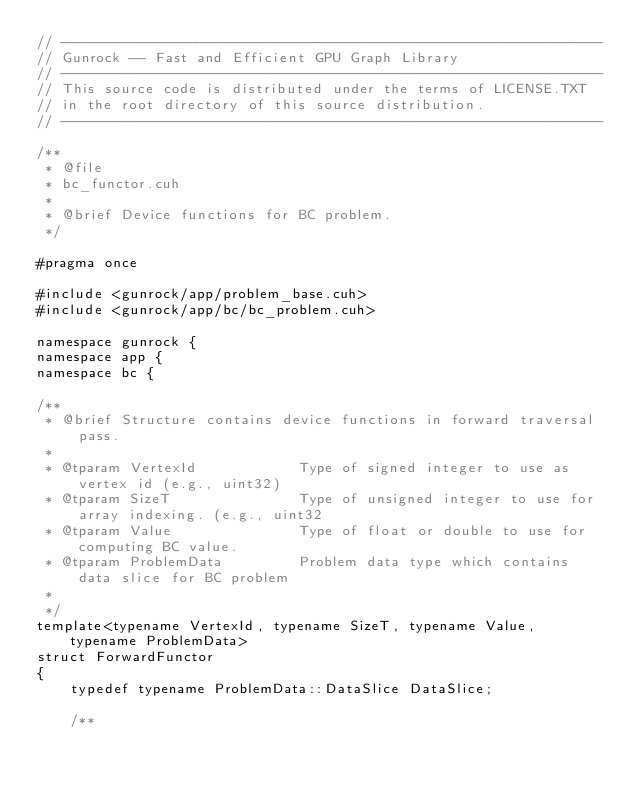Convert code to text. <code><loc_0><loc_0><loc_500><loc_500><_Cuda_>// ----------------------------------------------------------------
// Gunrock -- Fast and Efficient GPU Graph Library
// ----------------------------------------------------------------
// This source code is distributed under the terms of LICENSE.TXT
// in the root directory of this source distribution.
// ----------------------------------------------------------------

/**
 * @file
 * bc_functor.cuh
 *
 * @brief Device functions for BC problem.
 */

#pragma once

#include <gunrock/app/problem_base.cuh>
#include <gunrock/app/bc/bc_problem.cuh>

namespace gunrock {
namespace app {
namespace bc {

/**
 * @brief Structure contains device functions in forward traversal pass.
 *
 * @tparam VertexId            Type of signed integer to use as vertex id (e.g., uint32)
 * @tparam SizeT               Type of unsigned integer to use for array indexing. (e.g., uint32
 * @tparam Value               Type of float or double to use for computing BC value.
 * @tparam ProblemData         Problem data type which contains data slice for BC problem
 *
 */
template<typename VertexId, typename SizeT, typename Value, typename ProblemData>
struct ForwardFunctor
{
    typedef typename ProblemData::DataSlice DataSlice;

    /**</code> 